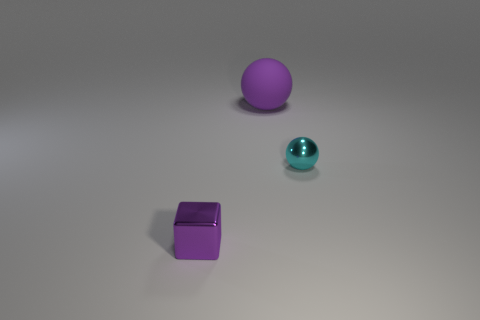There is a tiny metal thing right of the big ball; does it have the same color as the small object to the left of the matte object?
Offer a very short reply. No. What material is the object that is the same size as the cube?
Keep it short and to the point. Metal. Is there a purple rubber sphere that has the same size as the purple matte object?
Give a very brief answer. No. Is the number of cyan metal objects that are behind the cyan shiny sphere less than the number of small cyan objects?
Provide a succinct answer. Yes. Are there fewer large purple matte balls right of the purple rubber sphere than cubes that are behind the tiny metal cube?
Provide a short and direct response. No. What number of cylinders are either tiny purple things or big purple objects?
Keep it short and to the point. 0. Are the tiny object on the left side of the purple rubber object and the purple thing behind the small block made of the same material?
Provide a short and direct response. No. There is a purple shiny thing that is the same size as the shiny ball; what shape is it?
Provide a short and direct response. Cube. What number of other objects are the same color as the rubber thing?
Offer a very short reply. 1. How many green objects are either shiny spheres or metallic things?
Provide a succinct answer. 0. 